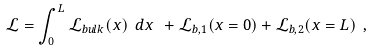Convert formula to latex. <formula><loc_0><loc_0><loc_500><loc_500>\mathcal { L } = \int _ { 0 } ^ { L } \mathcal { L } _ { b u l k } ( x ) \ d x \ + \mathcal { L } _ { b , 1 } ( x = 0 ) + \mathcal { L } _ { b , 2 } ( x = L ) \ ,</formula> 